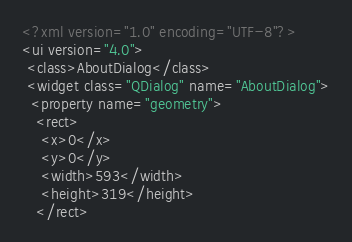<code> <loc_0><loc_0><loc_500><loc_500><_XML_><?xml version="1.0" encoding="UTF-8"?>
<ui version="4.0">
 <class>AboutDialog</class>
 <widget class="QDialog" name="AboutDialog">
  <property name="geometry">
   <rect>
    <x>0</x>
    <y>0</y>
    <width>593</width>
    <height>319</height>
   </rect></code> 